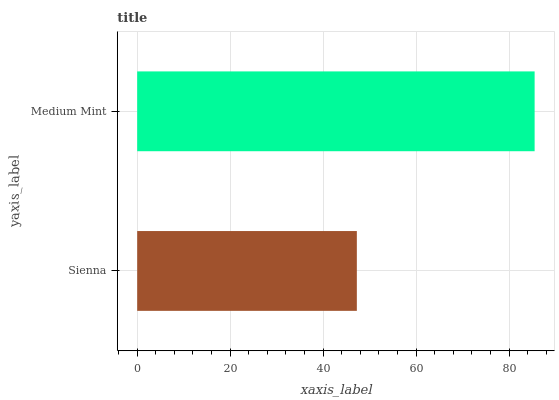Is Sienna the minimum?
Answer yes or no. Yes. Is Medium Mint the maximum?
Answer yes or no. Yes. Is Medium Mint the minimum?
Answer yes or no. No. Is Medium Mint greater than Sienna?
Answer yes or no. Yes. Is Sienna less than Medium Mint?
Answer yes or no. Yes. Is Sienna greater than Medium Mint?
Answer yes or no. No. Is Medium Mint less than Sienna?
Answer yes or no. No. Is Medium Mint the high median?
Answer yes or no. Yes. Is Sienna the low median?
Answer yes or no. Yes. Is Sienna the high median?
Answer yes or no. No. Is Medium Mint the low median?
Answer yes or no. No. 